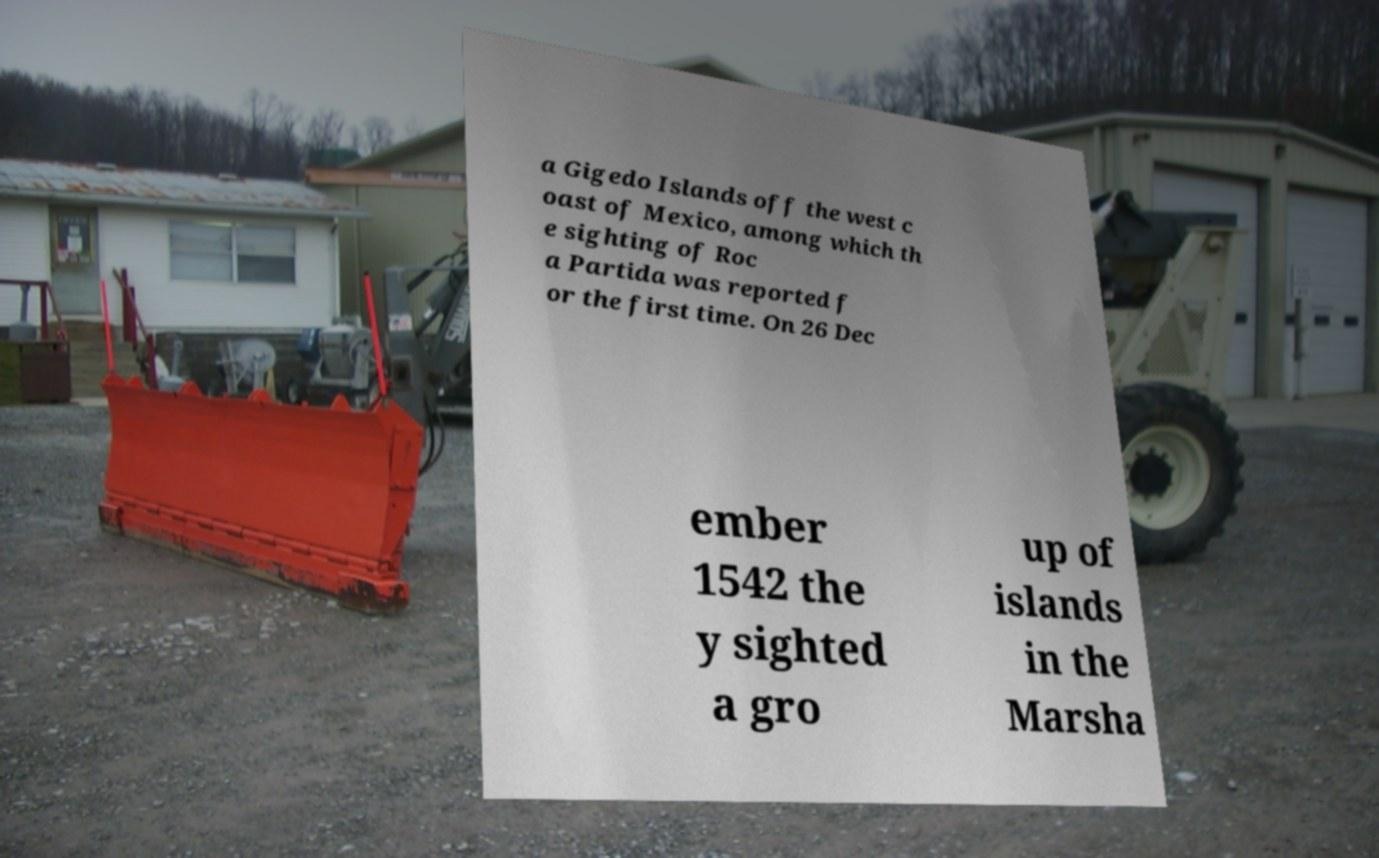What messages or text are displayed in this image? I need them in a readable, typed format. a Gigedo Islands off the west c oast of Mexico, among which th e sighting of Roc a Partida was reported f or the first time. On 26 Dec ember 1542 the y sighted a gro up of islands in the Marsha 